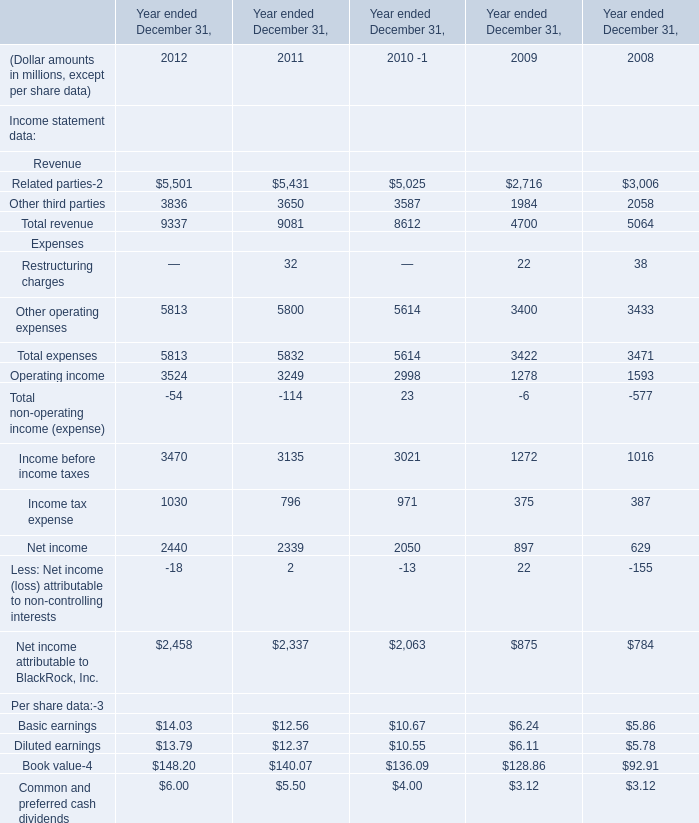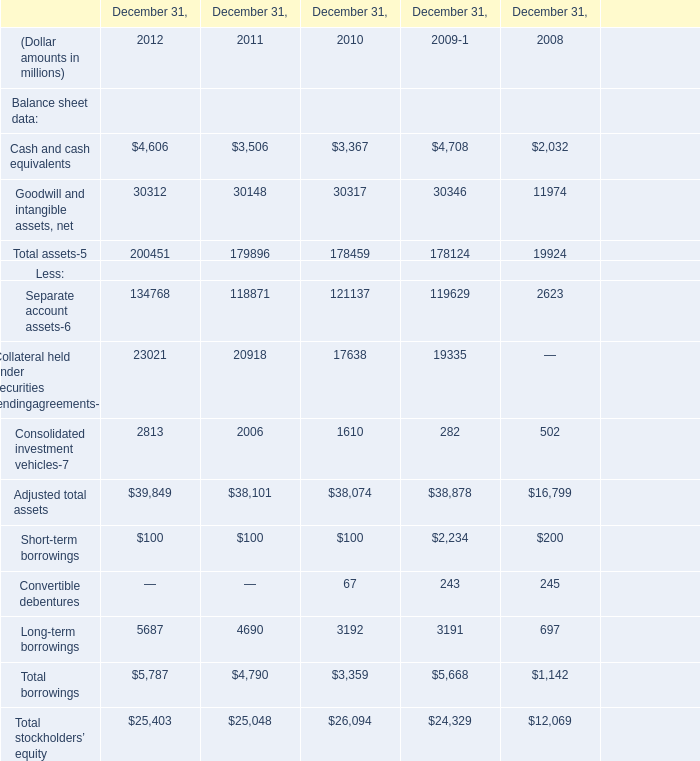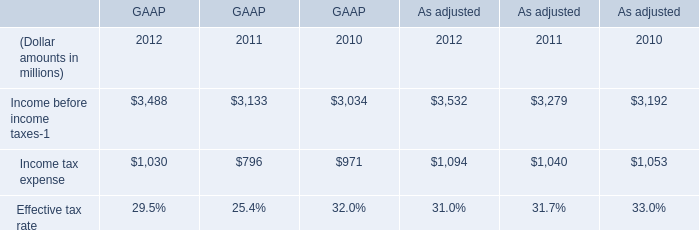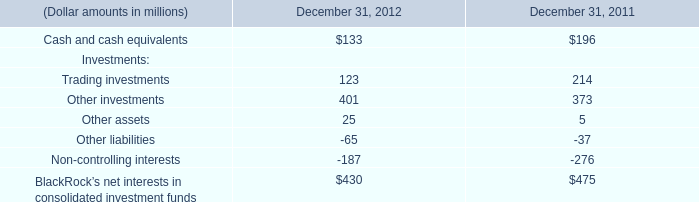What's the increasing rate of Cash and cash equivalents in 2012? 
Computations: ((4606 - 3506) / 3506)
Answer: 0.31375. 